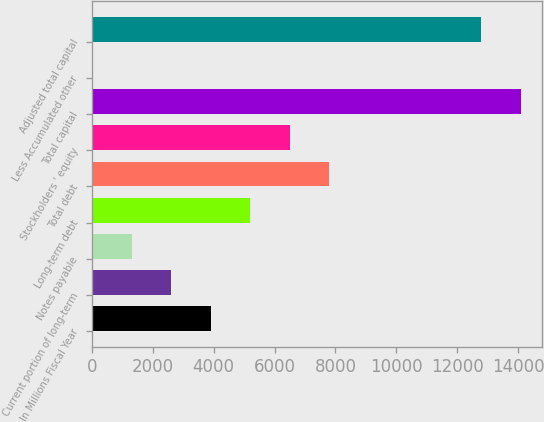<chart> <loc_0><loc_0><loc_500><loc_500><bar_chart><fcel>In Millions Fiscal Year<fcel>Current portion of long-term<fcel>Notes payable<fcel>Long-term debt<fcel>Total debt<fcel>Stockholders ' equity<fcel>Total capital<fcel>Less Accumulated other<fcel>Adjusted total capital<nl><fcel>3905.9<fcel>2606.6<fcel>1307.3<fcel>5205.2<fcel>7803.8<fcel>6504.5<fcel>14095.3<fcel>8<fcel>12796<nl></chart> 